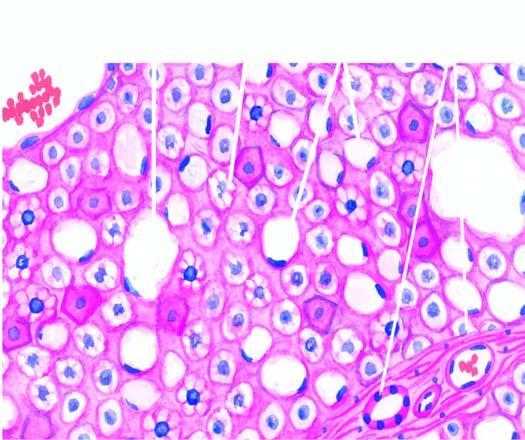re m phase distended with large fat vacuoles pushing the nuclei to the periphery macrovesicles, while others show multiple small vacuoles in the cytoplasm microvesicles?
Answer the question using a single word or phrase. No 